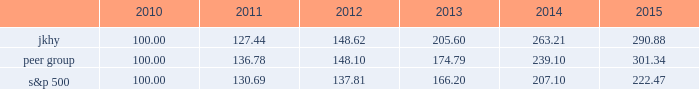18 2015 annual report performance graph the following chart presents a comparison for the five-year period ended june 30 , 2015 , of the market performance of the company 2019s common stock with the s&p 500 index and an index of peer companies selected by the company : comparison of 5 year cumulative total return among jack henry & associates , inc. , the s&p 500 index , and a peer group the following information depicts a line graph with the following values: .
This comparison assumes $ 100 was invested on june 30 , 2010 , and assumes reinvestments of dividends .
Total returns are calculated according to market capitalization of peer group members at the beginning of each period .
Peer companies selected are in the business of providing specialized computer software , hardware and related services to financial institutions and other businesses .
Companies in the peer group are aci worldwide , inc. , bottomline technology , inc. , broadridge financial solutions , cardtronics , inc. , convergys corp. , corelogic , inc. , dst systems , inc. , euronet worldwide , inc. , fair isaac corp. , fidelity national information services , inc. , fiserv , inc. , global payments , inc. , heartland payment systems , inc. , moneygram international , inc. , ss&c technologies holdings , inc. , total systems services , inc. , tyler technologies , inc. , verifone systems , inc. , and wex , inc. .
Micros systems , inc .
Was removed from the peer group as it was acquired in september 2014. .
For the 2010 , what was the cumulative total return on jkhy? 
Computations: (127.44 - 100.00)
Answer: 27.44. 